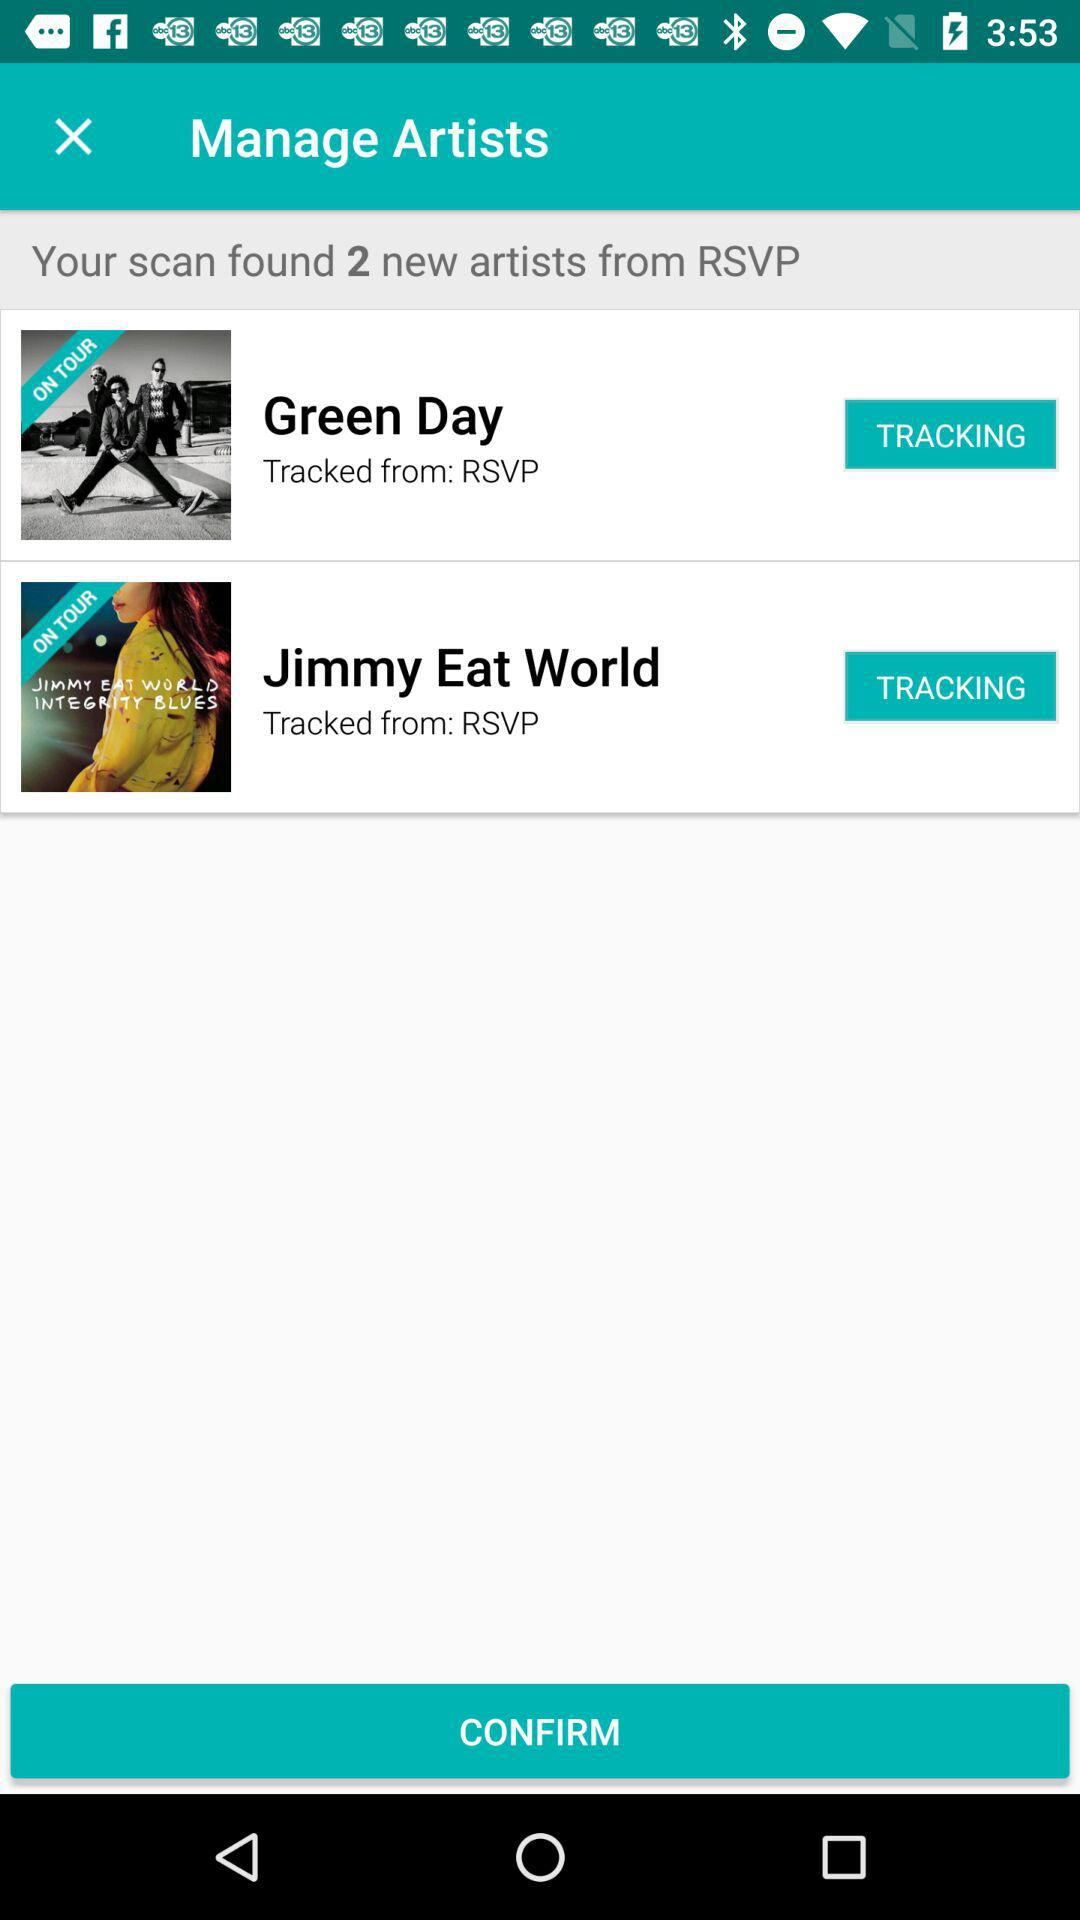How many artists are on tour?
Answer the question using a single word or phrase. 2 